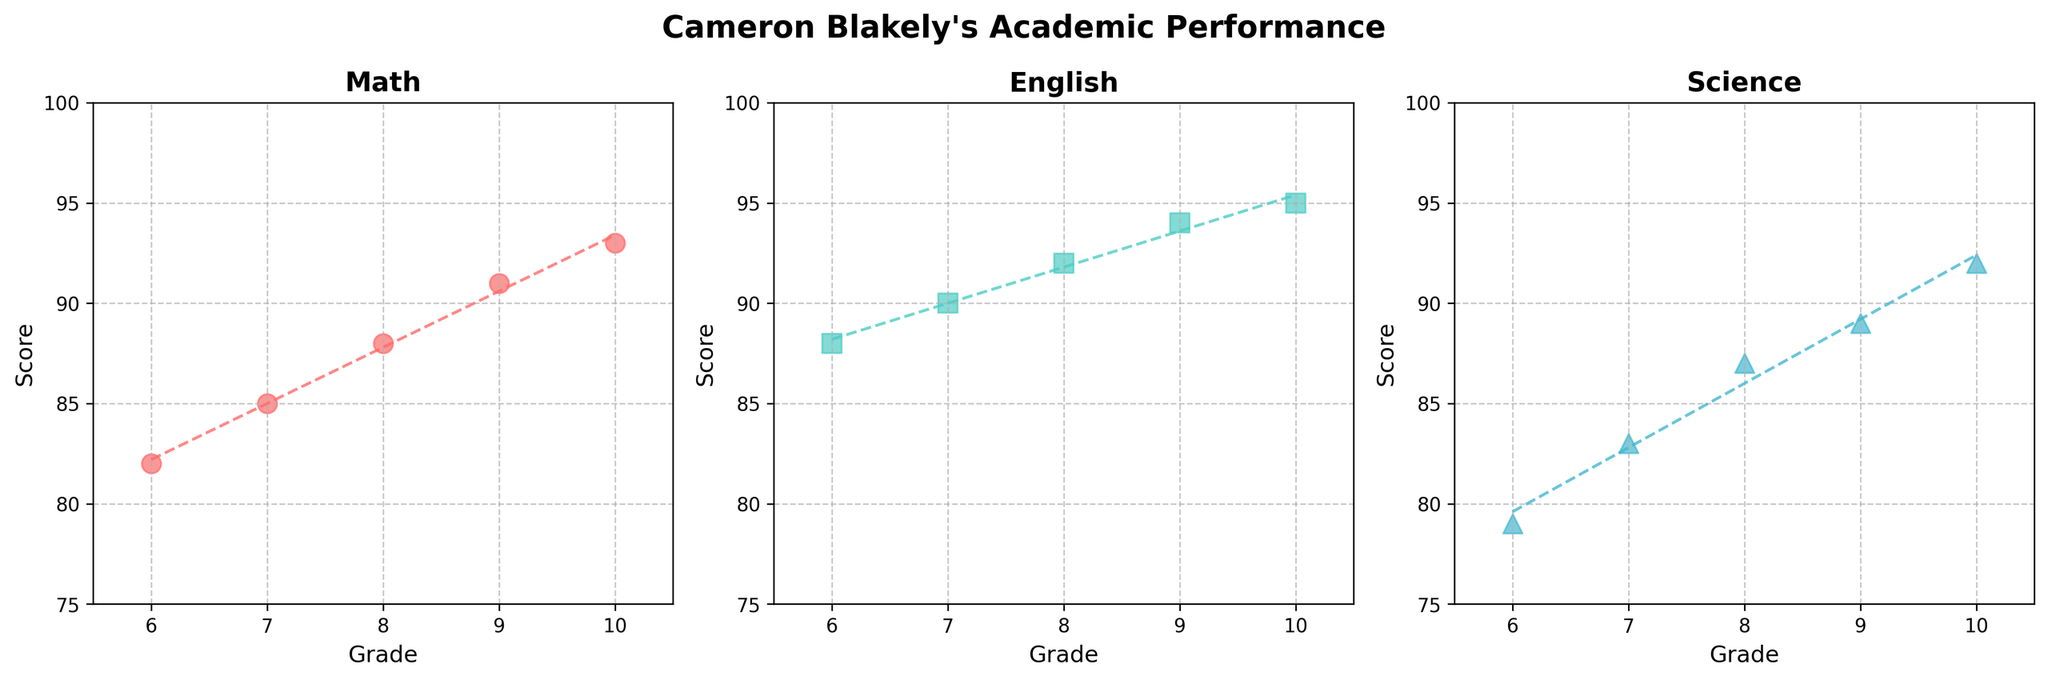What is the trend of Cameron Blakely’s Math scores from grade 6 to grade 10? The Math scores show a steady increase over the grades from 82 (grade 6) to 93 (grade 10). Each grade level shows an improvement over the previous one.
Answer: Steady increase What subject shows the highest improvement in scores over the grades? To determine which subject shows the highest improvement, compare the initial and final scores across grades for each subject. Math scores increased from 82 to 93, English from 88 to 95, and Science from 79 to 92. The highest improvement is in Science (an increase of 13 points).
Answer: Science How does Cameron Blakely’s English score in grade 8 compare to the Science score in grade 8? Referring to the scatter plots, the English score in grade 8 is 92 and the Science score in grade 8 is 87. English outperforms Science by 5 points in grade 8.
Answer: English is 5 points higher How many subjects did Cameron Blakely score above 90 in grade 10? Looking at the scatter plots for grade 10, Cameron's scores in Math, English, and Science are 93, 95, and 92, respectively. Since all these scores are above 90, Cameron scored above 90 in all three subjects.
Answer: Three subjects For which grade does Cameron Blakely have the highest overall average score across all subjects? To find the highest overall average, calculate the average score for each grade. 
Grade 6: (82+88+79)/3 = 83
Grade 7: (85+90+83)/3 = 86
Grade 8: (88+92+87)/3 = 89
Grade 9: (91+94+89)/3 = 91.33
Grade 10: (93+95+92)/3 = 93.33
The highest average is in grade 10 with 93.33.
Answer: Grade 10 What can be inferred about the general trend in Cameron Blakely's academic performance? The scatter plots show a positive trend in all subjects, indicating that Cameron's performance has consistently improved in each subject from grade 6 to grade 10.
Answer: Consistent improvement What is the slope of the trend line for Cameron Blakely's Science scores? The slope of the trend line can be estimated from the polyfit function, which fits a line to the data. The slope for Science would be derived from a linear regression of her grades (6 to 10) against her Science scores (79 to 92). Given these data points, the slope represents the average increase in score per grade.
Answer: Approximately 3.25 